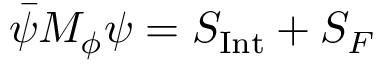Convert formula to latex. <formula><loc_0><loc_0><loc_500><loc_500>\bar { \psi } M _ { \phi } \psi = S _ { I n t } + S _ { F }</formula> 